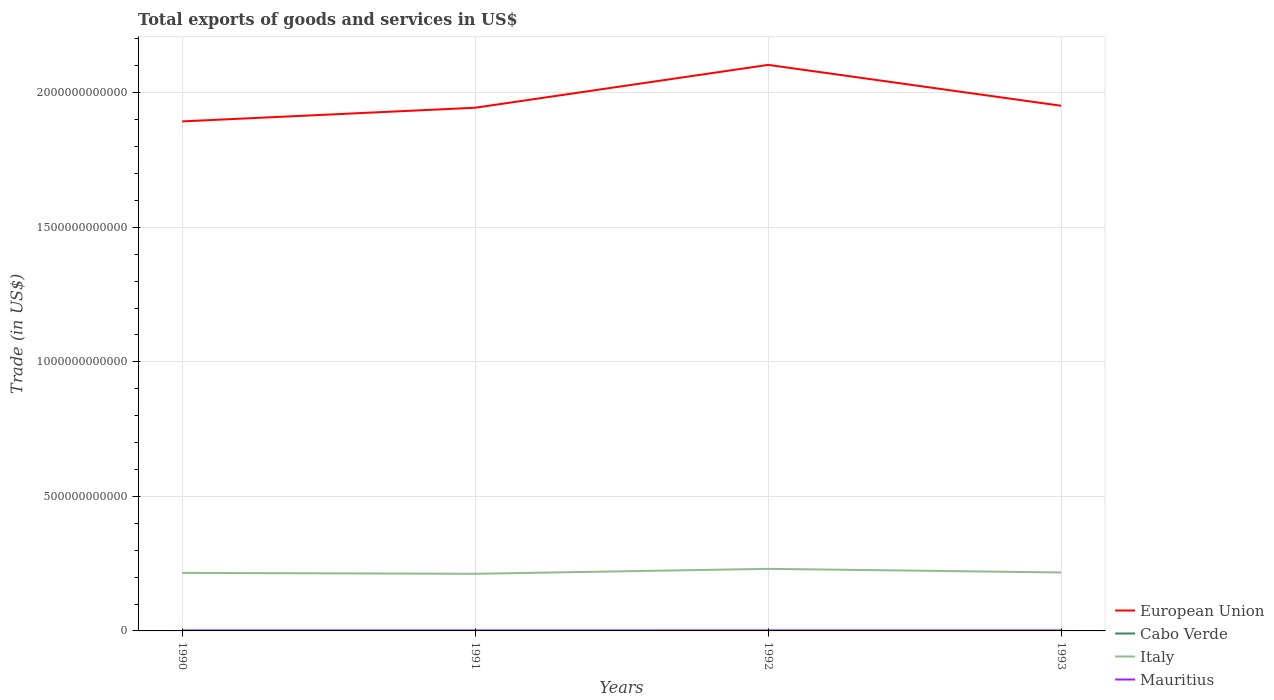How many different coloured lines are there?
Give a very brief answer. 4. Does the line corresponding to European Union intersect with the line corresponding to Mauritius?
Your answer should be compact. No. Across all years, what is the maximum total exports of goods and services in Mauritius?
Your answer should be very brief. 1.72e+09. In which year was the total exports of goods and services in European Union maximum?
Keep it short and to the point. 1990. What is the total total exports of goods and services in Cabo Verde in the graph?
Offer a terse response. -8.75e+06. What is the difference between the highest and the second highest total exports of goods and services in European Union?
Offer a terse response. 2.10e+11. What is the difference between the highest and the lowest total exports of goods and services in Italy?
Provide a short and direct response. 1. Is the total exports of goods and services in Cabo Verde strictly greater than the total exports of goods and services in European Union over the years?
Your answer should be compact. Yes. How many years are there in the graph?
Offer a very short reply. 4. What is the difference between two consecutive major ticks on the Y-axis?
Make the answer very short. 5.00e+11. Are the values on the major ticks of Y-axis written in scientific E-notation?
Offer a terse response. No. Does the graph contain grids?
Offer a terse response. Yes. What is the title of the graph?
Your answer should be very brief. Total exports of goods and services in US$. What is the label or title of the Y-axis?
Ensure brevity in your answer.  Trade (in US$). What is the Trade (in US$) of European Union in 1990?
Give a very brief answer. 1.89e+12. What is the Trade (in US$) of Cabo Verde in 1990?
Ensure brevity in your answer.  5.26e+07. What is the Trade (in US$) of Italy in 1990?
Offer a very short reply. 2.16e+11. What is the Trade (in US$) of Mauritius in 1990?
Provide a short and direct response. 1.72e+09. What is the Trade (in US$) in European Union in 1991?
Your answer should be very brief. 1.94e+12. What is the Trade (in US$) of Cabo Verde in 1991?
Give a very brief answer. 5.30e+07. What is the Trade (in US$) of Italy in 1991?
Your answer should be very brief. 2.12e+11. What is the Trade (in US$) in Mauritius in 1991?
Keep it short and to the point. 1.78e+09. What is the Trade (in US$) in European Union in 1992?
Ensure brevity in your answer.  2.10e+12. What is the Trade (in US$) of Cabo Verde in 1992?
Keep it short and to the point. 6.17e+07. What is the Trade (in US$) in Italy in 1992?
Your response must be concise. 2.31e+11. What is the Trade (in US$) of Mauritius in 1992?
Provide a short and direct response. 1.91e+09. What is the Trade (in US$) of European Union in 1993?
Your answer should be very brief. 1.95e+12. What is the Trade (in US$) in Cabo Verde in 1993?
Ensure brevity in your answer.  6.50e+07. What is the Trade (in US$) of Italy in 1993?
Your answer should be very brief. 2.17e+11. What is the Trade (in US$) in Mauritius in 1993?
Offer a terse response. 1.90e+09. Across all years, what is the maximum Trade (in US$) of European Union?
Give a very brief answer. 2.10e+12. Across all years, what is the maximum Trade (in US$) of Cabo Verde?
Provide a short and direct response. 6.50e+07. Across all years, what is the maximum Trade (in US$) of Italy?
Keep it short and to the point. 2.31e+11. Across all years, what is the maximum Trade (in US$) in Mauritius?
Provide a short and direct response. 1.91e+09. Across all years, what is the minimum Trade (in US$) of European Union?
Your answer should be compact. 1.89e+12. Across all years, what is the minimum Trade (in US$) of Cabo Verde?
Make the answer very short. 5.26e+07. Across all years, what is the minimum Trade (in US$) in Italy?
Offer a very short reply. 2.12e+11. Across all years, what is the minimum Trade (in US$) in Mauritius?
Provide a succinct answer. 1.72e+09. What is the total Trade (in US$) of European Union in the graph?
Ensure brevity in your answer.  7.89e+12. What is the total Trade (in US$) of Cabo Verde in the graph?
Offer a terse response. 2.32e+08. What is the total Trade (in US$) of Italy in the graph?
Your answer should be very brief. 8.76e+11. What is the total Trade (in US$) in Mauritius in the graph?
Make the answer very short. 7.32e+09. What is the difference between the Trade (in US$) in European Union in 1990 and that in 1991?
Offer a very short reply. -5.07e+1. What is the difference between the Trade (in US$) of Cabo Verde in 1990 and that in 1991?
Your answer should be very brief. -4.00e+05. What is the difference between the Trade (in US$) of Italy in 1990 and that in 1991?
Offer a very short reply. 3.38e+09. What is the difference between the Trade (in US$) in Mauritius in 1990 and that in 1991?
Your answer should be very brief. -5.64e+07. What is the difference between the Trade (in US$) of European Union in 1990 and that in 1992?
Offer a terse response. -2.10e+11. What is the difference between the Trade (in US$) of Cabo Verde in 1990 and that in 1992?
Provide a short and direct response. -9.15e+06. What is the difference between the Trade (in US$) in Italy in 1990 and that in 1992?
Your answer should be very brief. -1.51e+1. What is the difference between the Trade (in US$) of Mauritius in 1990 and that in 1992?
Your answer should be compact. -1.89e+08. What is the difference between the Trade (in US$) in European Union in 1990 and that in 1993?
Your answer should be very brief. -5.80e+1. What is the difference between the Trade (in US$) of Cabo Verde in 1990 and that in 1993?
Your response must be concise. -1.25e+07. What is the difference between the Trade (in US$) in Italy in 1990 and that in 1993?
Ensure brevity in your answer.  -1.56e+09. What is the difference between the Trade (in US$) in Mauritius in 1990 and that in 1993?
Provide a succinct answer. -1.77e+08. What is the difference between the Trade (in US$) in European Union in 1991 and that in 1992?
Offer a very short reply. -1.59e+11. What is the difference between the Trade (in US$) in Cabo Verde in 1991 and that in 1992?
Give a very brief answer. -8.75e+06. What is the difference between the Trade (in US$) in Italy in 1991 and that in 1992?
Provide a short and direct response. -1.84e+1. What is the difference between the Trade (in US$) of Mauritius in 1991 and that in 1992?
Your answer should be compact. -1.32e+08. What is the difference between the Trade (in US$) in European Union in 1991 and that in 1993?
Your answer should be compact. -7.28e+09. What is the difference between the Trade (in US$) in Cabo Verde in 1991 and that in 1993?
Make the answer very short. -1.21e+07. What is the difference between the Trade (in US$) in Italy in 1991 and that in 1993?
Your answer should be very brief. -4.93e+09. What is the difference between the Trade (in US$) in Mauritius in 1991 and that in 1993?
Offer a terse response. -1.21e+08. What is the difference between the Trade (in US$) in European Union in 1992 and that in 1993?
Make the answer very short. 1.52e+11. What is the difference between the Trade (in US$) in Cabo Verde in 1992 and that in 1993?
Your answer should be compact. -3.31e+06. What is the difference between the Trade (in US$) in Italy in 1992 and that in 1993?
Provide a short and direct response. 1.35e+1. What is the difference between the Trade (in US$) of Mauritius in 1992 and that in 1993?
Your answer should be compact. 1.15e+07. What is the difference between the Trade (in US$) in European Union in 1990 and the Trade (in US$) in Cabo Verde in 1991?
Offer a terse response. 1.89e+12. What is the difference between the Trade (in US$) in European Union in 1990 and the Trade (in US$) in Italy in 1991?
Provide a short and direct response. 1.68e+12. What is the difference between the Trade (in US$) of European Union in 1990 and the Trade (in US$) of Mauritius in 1991?
Offer a terse response. 1.89e+12. What is the difference between the Trade (in US$) of Cabo Verde in 1990 and the Trade (in US$) of Italy in 1991?
Offer a terse response. -2.12e+11. What is the difference between the Trade (in US$) of Cabo Verde in 1990 and the Trade (in US$) of Mauritius in 1991?
Provide a short and direct response. -1.73e+09. What is the difference between the Trade (in US$) in Italy in 1990 and the Trade (in US$) in Mauritius in 1991?
Your answer should be compact. 2.14e+11. What is the difference between the Trade (in US$) in European Union in 1990 and the Trade (in US$) in Cabo Verde in 1992?
Your answer should be very brief. 1.89e+12. What is the difference between the Trade (in US$) of European Union in 1990 and the Trade (in US$) of Italy in 1992?
Your answer should be very brief. 1.66e+12. What is the difference between the Trade (in US$) of European Union in 1990 and the Trade (in US$) of Mauritius in 1992?
Your response must be concise. 1.89e+12. What is the difference between the Trade (in US$) of Cabo Verde in 1990 and the Trade (in US$) of Italy in 1992?
Your response must be concise. -2.31e+11. What is the difference between the Trade (in US$) of Cabo Verde in 1990 and the Trade (in US$) of Mauritius in 1992?
Your answer should be very brief. -1.86e+09. What is the difference between the Trade (in US$) in Italy in 1990 and the Trade (in US$) in Mauritius in 1992?
Provide a succinct answer. 2.14e+11. What is the difference between the Trade (in US$) of European Union in 1990 and the Trade (in US$) of Cabo Verde in 1993?
Your answer should be very brief. 1.89e+12. What is the difference between the Trade (in US$) in European Union in 1990 and the Trade (in US$) in Italy in 1993?
Keep it short and to the point. 1.68e+12. What is the difference between the Trade (in US$) of European Union in 1990 and the Trade (in US$) of Mauritius in 1993?
Your answer should be compact. 1.89e+12. What is the difference between the Trade (in US$) of Cabo Verde in 1990 and the Trade (in US$) of Italy in 1993?
Make the answer very short. -2.17e+11. What is the difference between the Trade (in US$) in Cabo Verde in 1990 and the Trade (in US$) in Mauritius in 1993?
Your answer should be compact. -1.85e+09. What is the difference between the Trade (in US$) of Italy in 1990 and the Trade (in US$) of Mauritius in 1993?
Your answer should be compact. 2.14e+11. What is the difference between the Trade (in US$) in European Union in 1991 and the Trade (in US$) in Cabo Verde in 1992?
Your answer should be compact. 1.94e+12. What is the difference between the Trade (in US$) in European Union in 1991 and the Trade (in US$) in Italy in 1992?
Your answer should be very brief. 1.71e+12. What is the difference between the Trade (in US$) of European Union in 1991 and the Trade (in US$) of Mauritius in 1992?
Provide a succinct answer. 1.94e+12. What is the difference between the Trade (in US$) in Cabo Verde in 1991 and the Trade (in US$) in Italy in 1992?
Your answer should be very brief. -2.31e+11. What is the difference between the Trade (in US$) in Cabo Verde in 1991 and the Trade (in US$) in Mauritius in 1992?
Offer a terse response. -1.86e+09. What is the difference between the Trade (in US$) in Italy in 1991 and the Trade (in US$) in Mauritius in 1992?
Provide a short and direct response. 2.10e+11. What is the difference between the Trade (in US$) in European Union in 1991 and the Trade (in US$) in Cabo Verde in 1993?
Offer a terse response. 1.94e+12. What is the difference between the Trade (in US$) in European Union in 1991 and the Trade (in US$) in Italy in 1993?
Your answer should be compact. 1.73e+12. What is the difference between the Trade (in US$) of European Union in 1991 and the Trade (in US$) of Mauritius in 1993?
Provide a short and direct response. 1.94e+12. What is the difference between the Trade (in US$) in Cabo Verde in 1991 and the Trade (in US$) in Italy in 1993?
Give a very brief answer. -2.17e+11. What is the difference between the Trade (in US$) in Cabo Verde in 1991 and the Trade (in US$) in Mauritius in 1993?
Ensure brevity in your answer.  -1.85e+09. What is the difference between the Trade (in US$) in Italy in 1991 and the Trade (in US$) in Mauritius in 1993?
Your answer should be compact. 2.10e+11. What is the difference between the Trade (in US$) in European Union in 1992 and the Trade (in US$) in Cabo Verde in 1993?
Make the answer very short. 2.10e+12. What is the difference between the Trade (in US$) in European Union in 1992 and the Trade (in US$) in Italy in 1993?
Keep it short and to the point. 1.89e+12. What is the difference between the Trade (in US$) in European Union in 1992 and the Trade (in US$) in Mauritius in 1993?
Provide a short and direct response. 2.10e+12. What is the difference between the Trade (in US$) of Cabo Verde in 1992 and the Trade (in US$) of Italy in 1993?
Make the answer very short. -2.17e+11. What is the difference between the Trade (in US$) in Cabo Verde in 1992 and the Trade (in US$) in Mauritius in 1993?
Provide a succinct answer. -1.84e+09. What is the difference between the Trade (in US$) of Italy in 1992 and the Trade (in US$) of Mauritius in 1993?
Your answer should be very brief. 2.29e+11. What is the average Trade (in US$) of European Union per year?
Give a very brief answer. 1.97e+12. What is the average Trade (in US$) of Cabo Verde per year?
Provide a short and direct response. 5.81e+07. What is the average Trade (in US$) in Italy per year?
Offer a very short reply. 2.19e+11. What is the average Trade (in US$) of Mauritius per year?
Keep it short and to the point. 1.83e+09. In the year 1990, what is the difference between the Trade (in US$) in European Union and Trade (in US$) in Cabo Verde?
Ensure brevity in your answer.  1.89e+12. In the year 1990, what is the difference between the Trade (in US$) of European Union and Trade (in US$) of Italy?
Keep it short and to the point. 1.68e+12. In the year 1990, what is the difference between the Trade (in US$) of European Union and Trade (in US$) of Mauritius?
Your response must be concise. 1.89e+12. In the year 1990, what is the difference between the Trade (in US$) of Cabo Verde and Trade (in US$) of Italy?
Your response must be concise. -2.16e+11. In the year 1990, what is the difference between the Trade (in US$) in Cabo Verde and Trade (in US$) in Mauritius?
Make the answer very short. -1.67e+09. In the year 1990, what is the difference between the Trade (in US$) of Italy and Trade (in US$) of Mauritius?
Your response must be concise. 2.14e+11. In the year 1991, what is the difference between the Trade (in US$) of European Union and Trade (in US$) of Cabo Verde?
Keep it short and to the point. 1.94e+12. In the year 1991, what is the difference between the Trade (in US$) in European Union and Trade (in US$) in Italy?
Offer a terse response. 1.73e+12. In the year 1991, what is the difference between the Trade (in US$) of European Union and Trade (in US$) of Mauritius?
Give a very brief answer. 1.94e+12. In the year 1991, what is the difference between the Trade (in US$) of Cabo Verde and Trade (in US$) of Italy?
Keep it short and to the point. -2.12e+11. In the year 1991, what is the difference between the Trade (in US$) in Cabo Verde and Trade (in US$) in Mauritius?
Provide a short and direct response. -1.73e+09. In the year 1991, what is the difference between the Trade (in US$) of Italy and Trade (in US$) of Mauritius?
Provide a short and direct response. 2.10e+11. In the year 1992, what is the difference between the Trade (in US$) in European Union and Trade (in US$) in Cabo Verde?
Make the answer very short. 2.10e+12. In the year 1992, what is the difference between the Trade (in US$) in European Union and Trade (in US$) in Italy?
Your answer should be very brief. 1.87e+12. In the year 1992, what is the difference between the Trade (in US$) in European Union and Trade (in US$) in Mauritius?
Ensure brevity in your answer.  2.10e+12. In the year 1992, what is the difference between the Trade (in US$) of Cabo Verde and Trade (in US$) of Italy?
Provide a succinct answer. -2.31e+11. In the year 1992, what is the difference between the Trade (in US$) of Cabo Verde and Trade (in US$) of Mauritius?
Offer a very short reply. -1.85e+09. In the year 1992, what is the difference between the Trade (in US$) in Italy and Trade (in US$) in Mauritius?
Provide a short and direct response. 2.29e+11. In the year 1993, what is the difference between the Trade (in US$) of European Union and Trade (in US$) of Cabo Verde?
Offer a terse response. 1.95e+12. In the year 1993, what is the difference between the Trade (in US$) in European Union and Trade (in US$) in Italy?
Give a very brief answer. 1.73e+12. In the year 1993, what is the difference between the Trade (in US$) in European Union and Trade (in US$) in Mauritius?
Ensure brevity in your answer.  1.95e+12. In the year 1993, what is the difference between the Trade (in US$) of Cabo Verde and Trade (in US$) of Italy?
Ensure brevity in your answer.  -2.17e+11. In the year 1993, what is the difference between the Trade (in US$) of Cabo Verde and Trade (in US$) of Mauritius?
Your answer should be very brief. -1.84e+09. In the year 1993, what is the difference between the Trade (in US$) in Italy and Trade (in US$) in Mauritius?
Offer a terse response. 2.15e+11. What is the ratio of the Trade (in US$) of European Union in 1990 to that in 1991?
Your answer should be compact. 0.97. What is the ratio of the Trade (in US$) of Cabo Verde in 1990 to that in 1991?
Give a very brief answer. 0.99. What is the ratio of the Trade (in US$) of Italy in 1990 to that in 1991?
Make the answer very short. 1.02. What is the ratio of the Trade (in US$) in Mauritius in 1990 to that in 1991?
Provide a succinct answer. 0.97. What is the ratio of the Trade (in US$) in European Union in 1990 to that in 1992?
Keep it short and to the point. 0.9. What is the ratio of the Trade (in US$) in Cabo Verde in 1990 to that in 1992?
Offer a terse response. 0.85. What is the ratio of the Trade (in US$) in Italy in 1990 to that in 1992?
Your answer should be very brief. 0.93. What is the ratio of the Trade (in US$) of Mauritius in 1990 to that in 1992?
Keep it short and to the point. 0.9. What is the ratio of the Trade (in US$) of European Union in 1990 to that in 1993?
Offer a very short reply. 0.97. What is the ratio of the Trade (in US$) of Cabo Verde in 1990 to that in 1993?
Provide a succinct answer. 0.81. What is the ratio of the Trade (in US$) in Mauritius in 1990 to that in 1993?
Keep it short and to the point. 0.91. What is the ratio of the Trade (in US$) of European Union in 1991 to that in 1992?
Offer a very short reply. 0.92. What is the ratio of the Trade (in US$) in Cabo Verde in 1991 to that in 1992?
Ensure brevity in your answer.  0.86. What is the ratio of the Trade (in US$) in Italy in 1991 to that in 1992?
Your answer should be very brief. 0.92. What is the ratio of the Trade (in US$) in Mauritius in 1991 to that in 1992?
Give a very brief answer. 0.93. What is the ratio of the Trade (in US$) in Cabo Verde in 1991 to that in 1993?
Make the answer very short. 0.81. What is the ratio of the Trade (in US$) in Italy in 1991 to that in 1993?
Make the answer very short. 0.98. What is the ratio of the Trade (in US$) in Mauritius in 1991 to that in 1993?
Keep it short and to the point. 0.94. What is the ratio of the Trade (in US$) in European Union in 1992 to that in 1993?
Offer a very short reply. 1.08. What is the ratio of the Trade (in US$) in Cabo Verde in 1992 to that in 1993?
Your response must be concise. 0.95. What is the ratio of the Trade (in US$) in Italy in 1992 to that in 1993?
Ensure brevity in your answer.  1.06. What is the difference between the highest and the second highest Trade (in US$) of European Union?
Your response must be concise. 1.52e+11. What is the difference between the highest and the second highest Trade (in US$) in Cabo Verde?
Keep it short and to the point. 3.31e+06. What is the difference between the highest and the second highest Trade (in US$) in Italy?
Provide a succinct answer. 1.35e+1. What is the difference between the highest and the second highest Trade (in US$) of Mauritius?
Give a very brief answer. 1.15e+07. What is the difference between the highest and the lowest Trade (in US$) in European Union?
Ensure brevity in your answer.  2.10e+11. What is the difference between the highest and the lowest Trade (in US$) in Cabo Verde?
Keep it short and to the point. 1.25e+07. What is the difference between the highest and the lowest Trade (in US$) in Italy?
Offer a terse response. 1.84e+1. What is the difference between the highest and the lowest Trade (in US$) of Mauritius?
Your answer should be compact. 1.89e+08. 